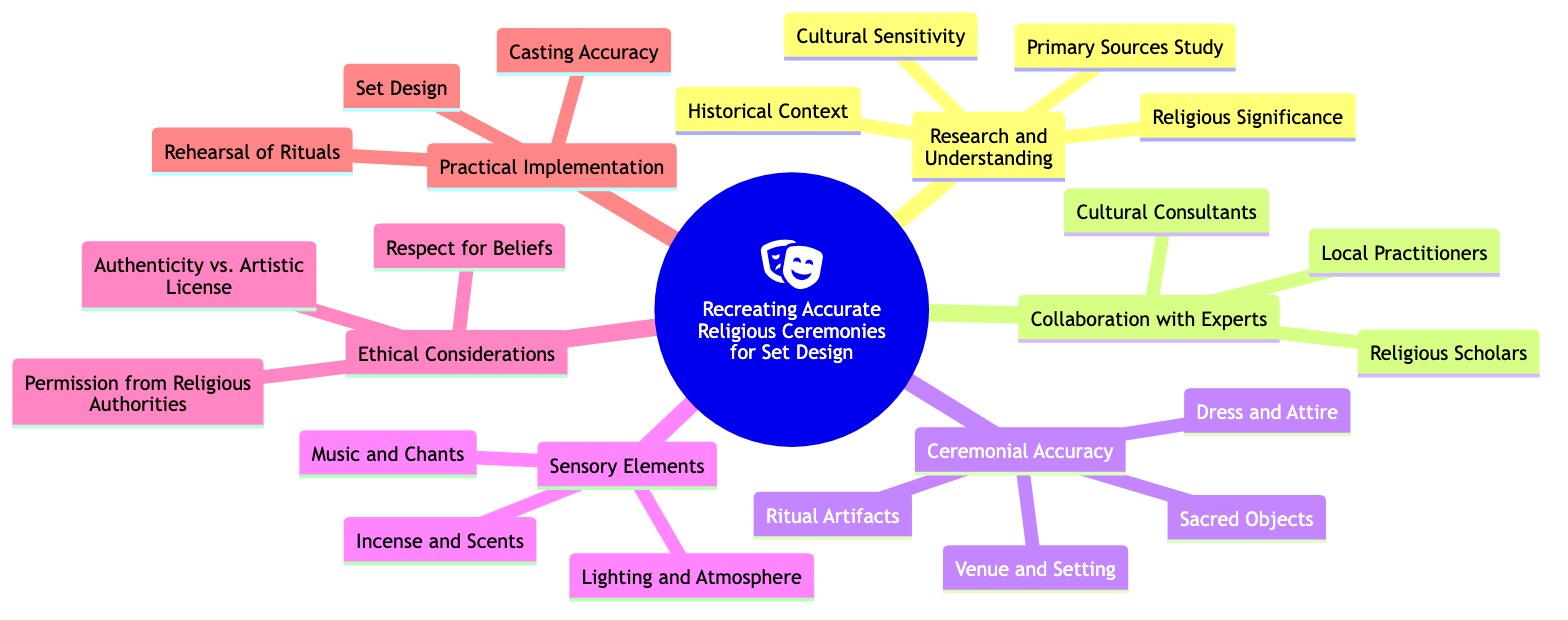What is the central topic of the diagram? The central topic is explicitly stated at the root node of the diagram, which is "Recreating Accurate Religious Ceremonies for Set Design."
Answer: Recreating Accurate Religious Ceremonies for Set Design How many subtopics are listed in the diagram? By counting the subtopics branching from the central topic, we observe there are six subtopics: Research and Understanding, Collaboration with Experts, Ceremonial Accuracy, Sensory Elements, Ethical Considerations, and Practical Implementation.
Answer: 6 Which subtopic includes "Dress and Attire"? "Dress and Attire" is listed under the subtopic of "Ceremonial Accuracy," which encompasses various aspects crucial for achieving accuracy in the representation of ceremonies.
Answer: Ceremonial Accuracy What does the subtopic "Collaboration with Experts" include? The subtopic "Collaboration with Experts" contains three elements: Religious Scholars, Cultural Consultants, and Local Practitioners. These roles are significant for ensuring authenticity and sensitivity in the set design process.
Answer: Religious Scholars, Cultural Consultants, Local Practitioners What are the two sensory elements mentioned in the diagram? The subtopic "Sensory Elements" lists three elements, and among them, two mentioned are "Music and Chants" and "Incense and Scents." These elements contribute to creating an immersive atmosphere during the ceremony.
Answer: Music and Chants, Incense and Scents Which ethical consideration addresses permission? The ethical consideration that specifically addresses permission is "Permission from Religious Authorities," emphasizing the necessity of obtaining consent to respect the beliefs of the community involved.
Answer: Permission from Religious Authorities Which elements are essential for "Practical Implementation"? "Practical Implementation" includes three essential elements: Set Design, Casting Accuracy, and Rehearsal of Rituals, indicating critical steps for executing the design accurately.
Answer: Set Design, Casting Accuracy, Rehearsal of Rituals What type of collaboration is emphasized in the diagram for religious ceremonies? Collaboration with experts is emphasized, particularly with specialists like Religious Scholars, Cultural Consultants, and Local Practitioners, to ensure religious and cultural accuracy in the ceremonies being recreated.
Answer: Collaboration with Experts 